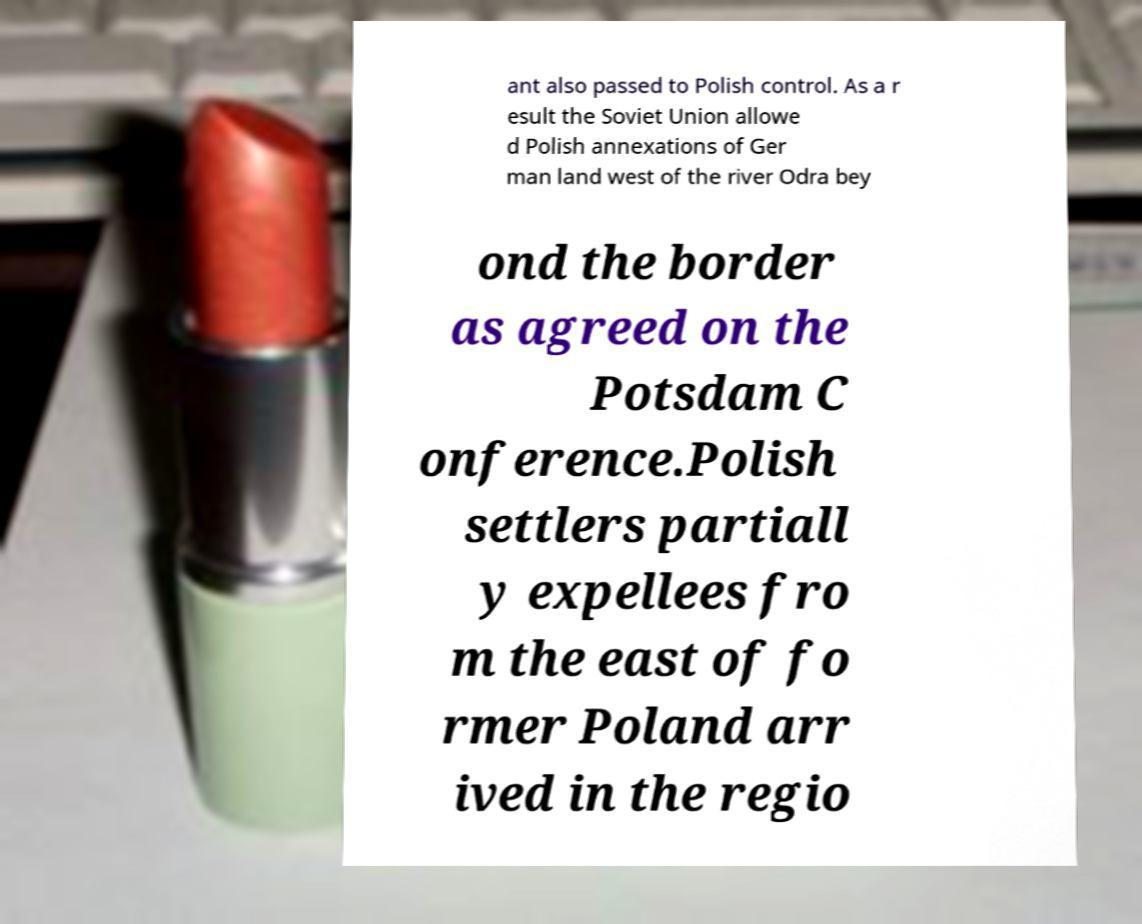For documentation purposes, I need the text within this image transcribed. Could you provide that? ant also passed to Polish control. As a r esult the Soviet Union allowe d Polish annexations of Ger man land west of the river Odra bey ond the border as agreed on the Potsdam C onference.Polish settlers partiall y expellees fro m the east of fo rmer Poland arr ived in the regio 